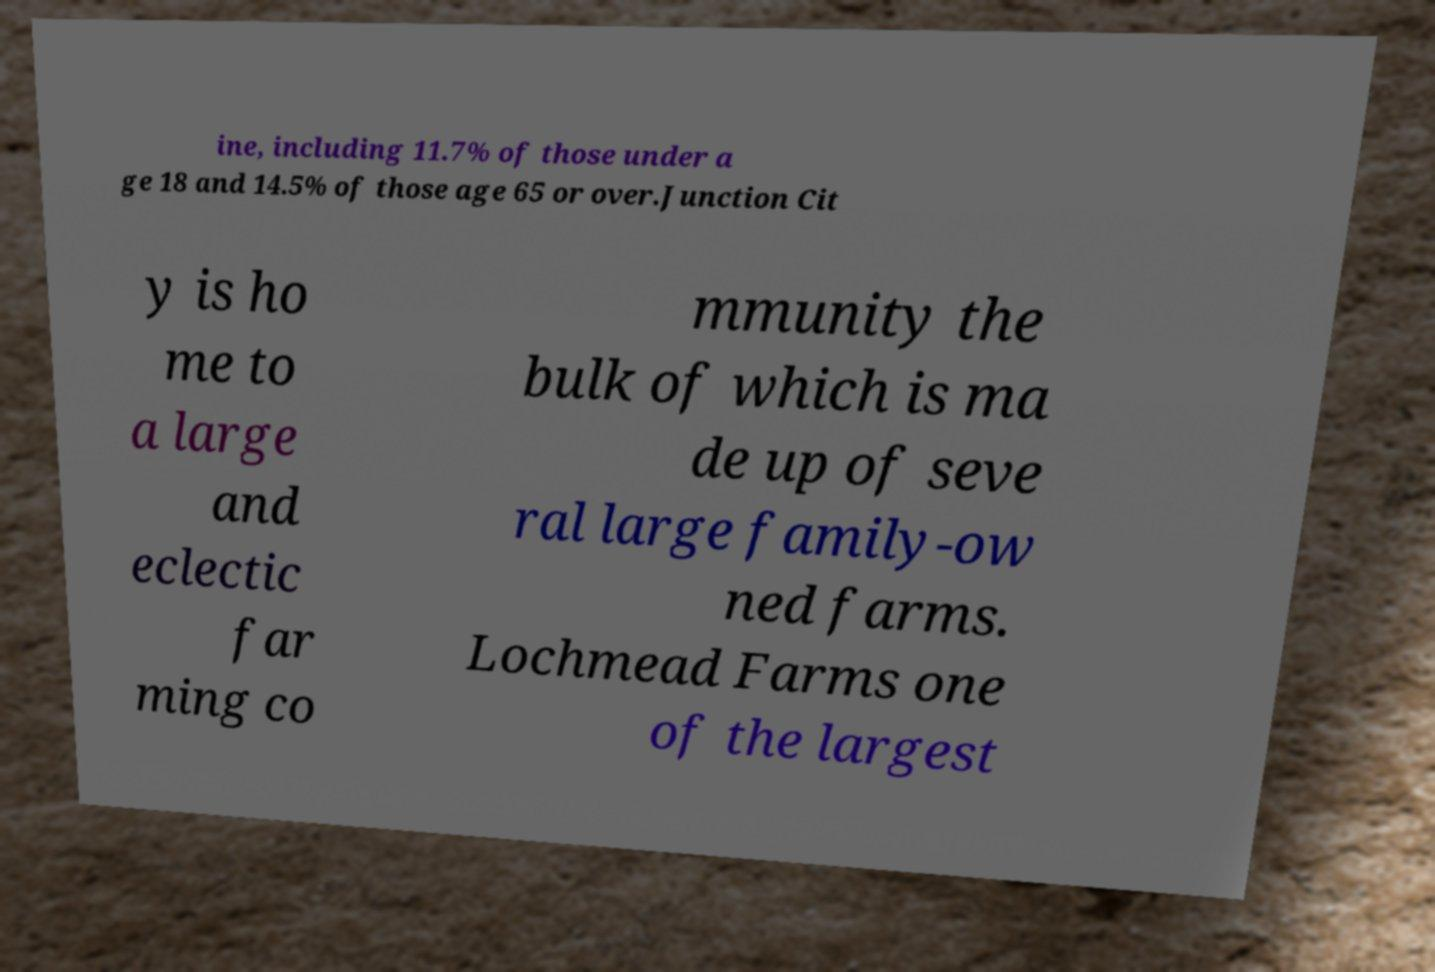I need the written content from this picture converted into text. Can you do that? ine, including 11.7% of those under a ge 18 and 14.5% of those age 65 or over.Junction Cit y is ho me to a large and eclectic far ming co mmunity the bulk of which is ma de up of seve ral large family-ow ned farms. Lochmead Farms one of the largest 